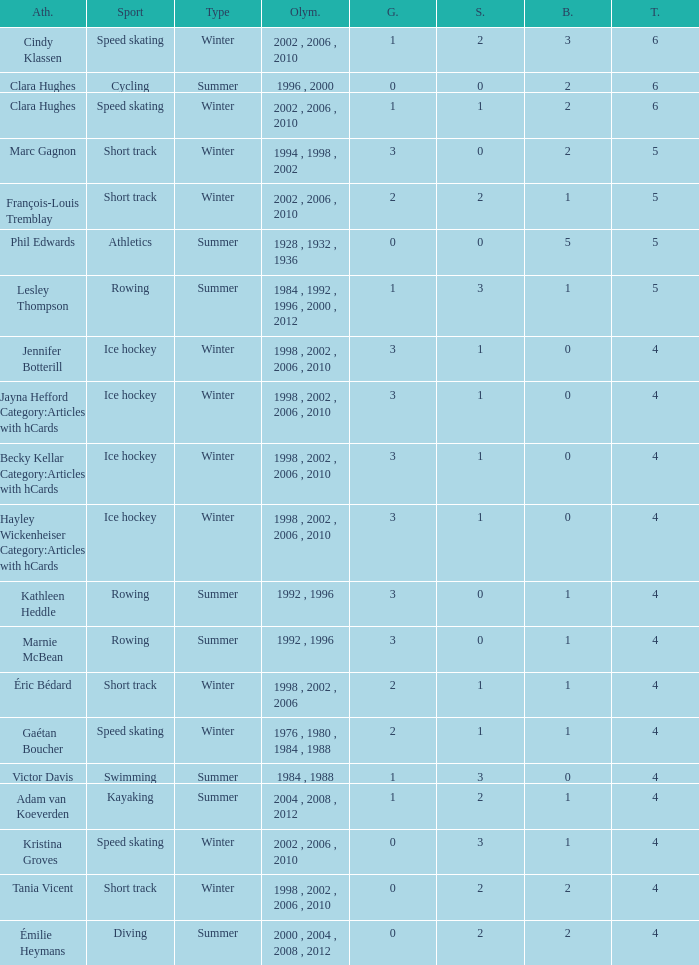What is the lowest number of bronze a short track athlete with 0 gold medals has? 2.0. 